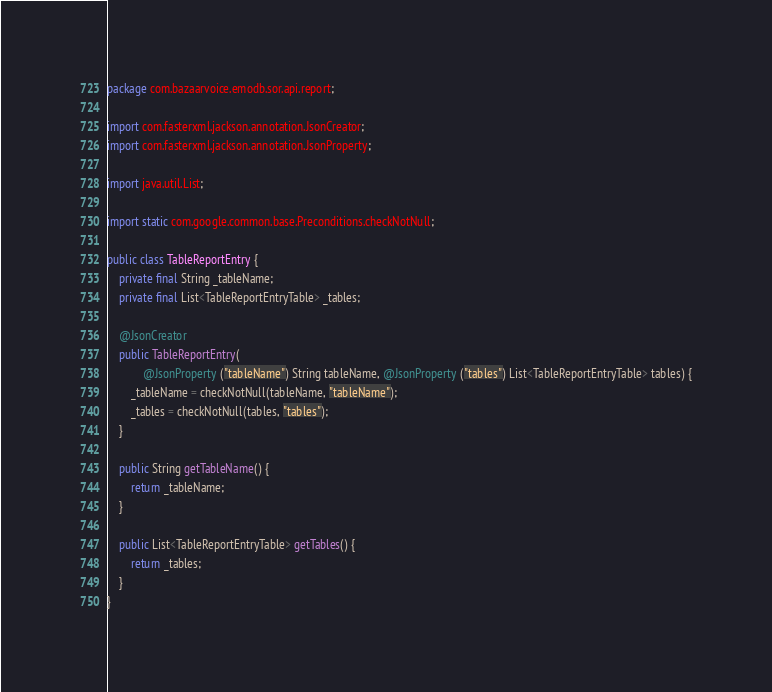<code> <loc_0><loc_0><loc_500><loc_500><_Java_>package com.bazaarvoice.emodb.sor.api.report;

import com.fasterxml.jackson.annotation.JsonCreator;
import com.fasterxml.jackson.annotation.JsonProperty;

import java.util.List;

import static com.google.common.base.Preconditions.checkNotNull;

public class TableReportEntry {
    private final String _tableName;
    private final List<TableReportEntryTable> _tables;

    @JsonCreator
    public TableReportEntry(
            @JsonProperty ("tableName") String tableName, @JsonProperty ("tables") List<TableReportEntryTable> tables) {
        _tableName = checkNotNull(tableName, "tableName");
        _tables = checkNotNull(tables, "tables");
    }

    public String getTableName() {
        return _tableName;
    }

    public List<TableReportEntryTable> getTables() {
        return _tables;
    }
}
</code> 